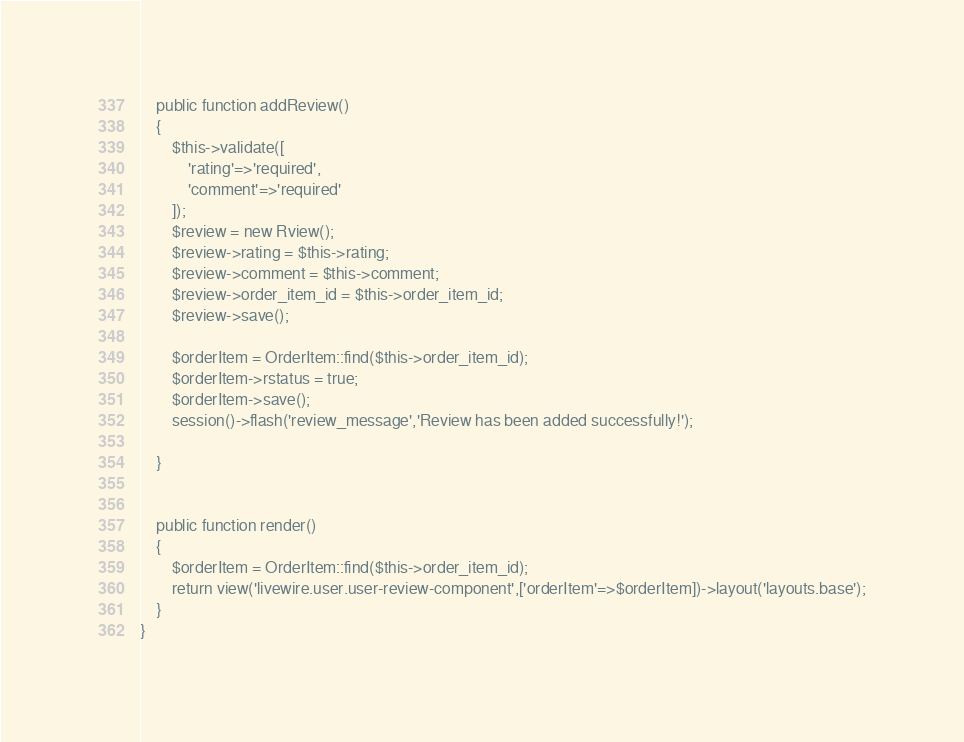Convert code to text. <code><loc_0><loc_0><loc_500><loc_500><_PHP_>    public function addReview()
    {
        $this->validate([
            'rating'=>'required',
            'comment'=>'required'
        ]);
        $review = new Rview();
        $review->rating = $this->rating;
        $review->comment = $this->comment;
        $review->order_item_id = $this->order_item_id;
        $review->save();

        $orderItem = OrderItem::find($this->order_item_id);
        $orderItem->rstatus = true;
        $orderItem->save();
        session()->flash('review_message','Review has been added successfully!');

    }


    public function render()
    {
        $orderItem = OrderItem::find($this->order_item_id);
        return view('livewire.user.user-review-component',['orderItem'=>$orderItem])->layout('layouts.base');
    }
}
</code> 